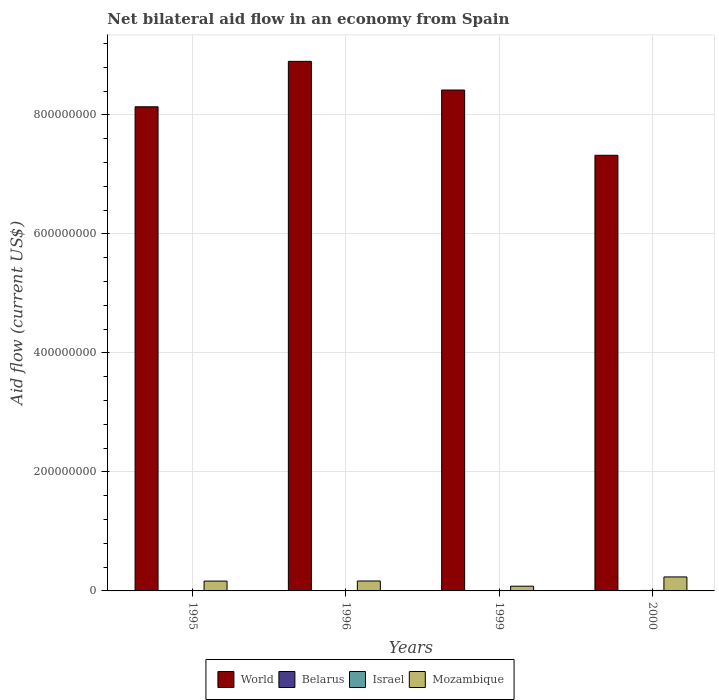In how many cases, is the number of bars for a given year not equal to the number of legend labels?
Make the answer very short. 0. What is the net bilateral aid flow in Belarus in 1996?
Keep it short and to the point. 2.50e+05. Across all years, what is the maximum net bilateral aid flow in Mozambique?
Your response must be concise. 2.35e+07. Across all years, what is the minimum net bilateral aid flow in World?
Give a very brief answer. 7.32e+08. In which year was the net bilateral aid flow in World maximum?
Offer a very short reply. 1996. In which year was the net bilateral aid flow in World minimum?
Offer a terse response. 2000. What is the total net bilateral aid flow in Belarus in the graph?
Keep it short and to the point. 5.80e+05. What is the difference between the net bilateral aid flow in Mozambique in 1996 and that in 1999?
Ensure brevity in your answer.  8.74e+06. What is the difference between the net bilateral aid flow in Belarus in 1996 and the net bilateral aid flow in World in 1999?
Make the answer very short. -8.42e+08. What is the average net bilateral aid flow in Mozambique per year?
Keep it short and to the point. 1.62e+07. What is the ratio of the net bilateral aid flow in Mozambique in 1995 to that in 2000?
Provide a short and direct response. 0.7. What is the difference between the highest and the second highest net bilateral aid flow in Mozambique?
Keep it short and to the point. 6.83e+06. What is the difference between the highest and the lowest net bilateral aid flow in Mozambique?
Ensure brevity in your answer.  1.56e+07. In how many years, is the net bilateral aid flow in Belarus greater than the average net bilateral aid flow in Belarus taken over all years?
Give a very brief answer. 2. Is it the case that in every year, the sum of the net bilateral aid flow in Israel and net bilateral aid flow in World is greater than the sum of net bilateral aid flow in Belarus and net bilateral aid flow in Mozambique?
Give a very brief answer. Yes. What does the 1st bar from the left in 2000 represents?
Give a very brief answer. World. Is it the case that in every year, the sum of the net bilateral aid flow in Israel and net bilateral aid flow in Mozambique is greater than the net bilateral aid flow in World?
Offer a terse response. No. How many bars are there?
Provide a succinct answer. 16. Are all the bars in the graph horizontal?
Provide a short and direct response. No. What is the difference between two consecutive major ticks on the Y-axis?
Offer a very short reply. 2.00e+08. Does the graph contain grids?
Ensure brevity in your answer.  Yes. Where does the legend appear in the graph?
Offer a terse response. Bottom center. How many legend labels are there?
Make the answer very short. 4. What is the title of the graph?
Your response must be concise. Net bilateral aid flow in an economy from Spain. What is the Aid flow (current US$) of World in 1995?
Provide a succinct answer. 8.14e+08. What is the Aid flow (current US$) of Belarus in 1995?
Ensure brevity in your answer.  2.50e+05. What is the Aid flow (current US$) of Israel in 1995?
Keep it short and to the point. 1.10e+05. What is the Aid flow (current US$) of Mozambique in 1995?
Ensure brevity in your answer.  1.65e+07. What is the Aid flow (current US$) of World in 1996?
Your answer should be compact. 8.90e+08. What is the Aid flow (current US$) in Israel in 1996?
Ensure brevity in your answer.  1.50e+05. What is the Aid flow (current US$) of Mozambique in 1996?
Provide a short and direct response. 1.67e+07. What is the Aid flow (current US$) of World in 1999?
Provide a short and direct response. 8.42e+08. What is the Aid flow (current US$) of Belarus in 1999?
Keep it short and to the point. 5.00e+04. What is the Aid flow (current US$) in Israel in 1999?
Offer a very short reply. 7.20e+05. What is the Aid flow (current US$) in Mozambique in 1999?
Make the answer very short. 7.95e+06. What is the Aid flow (current US$) of World in 2000?
Offer a very short reply. 7.32e+08. What is the Aid flow (current US$) in Israel in 2000?
Offer a terse response. 8.10e+05. What is the Aid flow (current US$) in Mozambique in 2000?
Give a very brief answer. 2.35e+07. Across all years, what is the maximum Aid flow (current US$) of World?
Ensure brevity in your answer.  8.90e+08. Across all years, what is the maximum Aid flow (current US$) in Belarus?
Make the answer very short. 2.50e+05. Across all years, what is the maximum Aid flow (current US$) in Israel?
Provide a succinct answer. 8.10e+05. Across all years, what is the maximum Aid flow (current US$) of Mozambique?
Provide a succinct answer. 2.35e+07. Across all years, what is the minimum Aid flow (current US$) in World?
Your response must be concise. 7.32e+08. Across all years, what is the minimum Aid flow (current US$) in Belarus?
Your answer should be compact. 3.00e+04. Across all years, what is the minimum Aid flow (current US$) in Mozambique?
Keep it short and to the point. 7.95e+06. What is the total Aid flow (current US$) in World in the graph?
Make the answer very short. 3.28e+09. What is the total Aid flow (current US$) in Belarus in the graph?
Keep it short and to the point. 5.80e+05. What is the total Aid flow (current US$) of Israel in the graph?
Ensure brevity in your answer.  1.79e+06. What is the total Aid flow (current US$) in Mozambique in the graph?
Offer a terse response. 6.47e+07. What is the difference between the Aid flow (current US$) of World in 1995 and that in 1996?
Ensure brevity in your answer.  -7.64e+07. What is the difference between the Aid flow (current US$) of Mozambique in 1995 and that in 1996?
Provide a succinct answer. -1.60e+05. What is the difference between the Aid flow (current US$) of World in 1995 and that in 1999?
Provide a succinct answer. -2.82e+07. What is the difference between the Aid flow (current US$) of Israel in 1995 and that in 1999?
Make the answer very short. -6.10e+05. What is the difference between the Aid flow (current US$) of Mozambique in 1995 and that in 1999?
Offer a very short reply. 8.58e+06. What is the difference between the Aid flow (current US$) of World in 1995 and that in 2000?
Offer a very short reply. 8.15e+07. What is the difference between the Aid flow (current US$) in Israel in 1995 and that in 2000?
Provide a succinct answer. -7.00e+05. What is the difference between the Aid flow (current US$) of Mozambique in 1995 and that in 2000?
Provide a short and direct response. -6.99e+06. What is the difference between the Aid flow (current US$) of World in 1996 and that in 1999?
Offer a terse response. 4.82e+07. What is the difference between the Aid flow (current US$) in Israel in 1996 and that in 1999?
Offer a terse response. -5.70e+05. What is the difference between the Aid flow (current US$) in Mozambique in 1996 and that in 1999?
Your answer should be compact. 8.74e+06. What is the difference between the Aid flow (current US$) of World in 1996 and that in 2000?
Offer a terse response. 1.58e+08. What is the difference between the Aid flow (current US$) in Israel in 1996 and that in 2000?
Your response must be concise. -6.60e+05. What is the difference between the Aid flow (current US$) in Mozambique in 1996 and that in 2000?
Keep it short and to the point. -6.83e+06. What is the difference between the Aid flow (current US$) of World in 1999 and that in 2000?
Your response must be concise. 1.10e+08. What is the difference between the Aid flow (current US$) in Mozambique in 1999 and that in 2000?
Offer a terse response. -1.56e+07. What is the difference between the Aid flow (current US$) of World in 1995 and the Aid flow (current US$) of Belarus in 1996?
Provide a succinct answer. 8.13e+08. What is the difference between the Aid flow (current US$) in World in 1995 and the Aid flow (current US$) in Israel in 1996?
Offer a terse response. 8.13e+08. What is the difference between the Aid flow (current US$) of World in 1995 and the Aid flow (current US$) of Mozambique in 1996?
Keep it short and to the point. 7.97e+08. What is the difference between the Aid flow (current US$) in Belarus in 1995 and the Aid flow (current US$) in Israel in 1996?
Your answer should be very brief. 1.00e+05. What is the difference between the Aid flow (current US$) in Belarus in 1995 and the Aid flow (current US$) in Mozambique in 1996?
Provide a short and direct response. -1.64e+07. What is the difference between the Aid flow (current US$) in Israel in 1995 and the Aid flow (current US$) in Mozambique in 1996?
Offer a terse response. -1.66e+07. What is the difference between the Aid flow (current US$) in World in 1995 and the Aid flow (current US$) in Belarus in 1999?
Make the answer very short. 8.14e+08. What is the difference between the Aid flow (current US$) of World in 1995 and the Aid flow (current US$) of Israel in 1999?
Keep it short and to the point. 8.13e+08. What is the difference between the Aid flow (current US$) of World in 1995 and the Aid flow (current US$) of Mozambique in 1999?
Provide a short and direct response. 8.06e+08. What is the difference between the Aid flow (current US$) in Belarus in 1995 and the Aid flow (current US$) in Israel in 1999?
Offer a terse response. -4.70e+05. What is the difference between the Aid flow (current US$) in Belarus in 1995 and the Aid flow (current US$) in Mozambique in 1999?
Ensure brevity in your answer.  -7.70e+06. What is the difference between the Aid flow (current US$) of Israel in 1995 and the Aid flow (current US$) of Mozambique in 1999?
Offer a terse response. -7.84e+06. What is the difference between the Aid flow (current US$) of World in 1995 and the Aid flow (current US$) of Belarus in 2000?
Offer a very short reply. 8.14e+08. What is the difference between the Aid flow (current US$) of World in 1995 and the Aid flow (current US$) of Israel in 2000?
Make the answer very short. 8.13e+08. What is the difference between the Aid flow (current US$) in World in 1995 and the Aid flow (current US$) in Mozambique in 2000?
Your answer should be compact. 7.90e+08. What is the difference between the Aid flow (current US$) of Belarus in 1995 and the Aid flow (current US$) of Israel in 2000?
Your answer should be very brief. -5.60e+05. What is the difference between the Aid flow (current US$) of Belarus in 1995 and the Aid flow (current US$) of Mozambique in 2000?
Your answer should be very brief. -2.33e+07. What is the difference between the Aid flow (current US$) in Israel in 1995 and the Aid flow (current US$) in Mozambique in 2000?
Make the answer very short. -2.34e+07. What is the difference between the Aid flow (current US$) of World in 1996 and the Aid flow (current US$) of Belarus in 1999?
Give a very brief answer. 8.90e+08. What is the difference between the Aid flow (current US$) in World in 1996 and the Aid flow (current US$) in Israel in 1999?
Offer a very short reply. 8.89e+08. What is the difference between the Aid flow (current US$) in World in 1996 and the Aid flow (current US$) in Mozambique in 1999?
Give a very brief answer. 8.82e+08. What is the difference between the Aid flow (current US$) of Belarus in 1996 and the Aid flow (current US$) of Israel in 1999?
Provide a succinct answer. -4.70e+05. What is the difference between the Aid flow (current US$) of Belarus in 1996 and the Aid flow (current US$) of Mozambique in 1999?
Provide a succinct answer. -7.70e+06. What is the difference between the Aid flow (current US$) in Israel in 1996 and the Aid flow (current US$) in Mozambique in 1999?
Your answer should be very brief. -7.80e+06. What is the difference between the Aid flow (current US$) in World in 1996 and the Aid flow (current US$) in Belarus in 2000?
Offer a very short reply. 8.90e+08. What is the difference between the Aid flow (current US$) of World in 1996 and the Aid flow (current US$) of Israel in 2000?
Provide a succinct answer. 8.89e+08. What is the difference between the Aid flow (current US$) of World in 1996 and the Aid flow (current US$) of Mozambique in 2000?
Provide a short and direct response. 8.66e+08. What is the difference between the Aid flow (current US$) of Belarus in 1996 and the Aid flow (current US$) of Israel in 2000?
Offer a very short reply. -5.60e+05. What is the difference between the Aid flow (current US$) in Belarus in 1996 and the Aid flow (current US$) in Mozambique in 2000?
Offer a very short reply. -2.33e+07. What is the difference between the Aid flow (current US$) in Israel in 1996 and the Aid flow (current US$) in Mozambique in 2000?
Give a very brief answer. -2.34e+07. What is the difference between the Aid flow (current US$) in World in 1999 and the Aid flow (current US$) in Belarus in 2000?
Provide a succinct answer. 8.42e+08. What is the difference between the Aid flow (current US$) in World in 1999 and the Aid flow (current US$) in Israel in 2000?
Give a very brief answer. 8.41e+08. What is the difference between the Aid flow (current US$) of World in 1999 and the Aid flow (current US$) of Mozambique in 2000?
Give a very brief answer. 8.18e+08. What is the difference between the Aid flow (current US$) in Belarus in 1999 and the Aid flow (current US$) in Israel in 2000?
Offer a terse response. -7.60e+05. What is the difference between the Aid flow (current US$) in Belarus in 1999 and the Aid flow (current US$) in Mozambique in 2000?
Give a very brief answer. -2.35e+07. What is the difference between the Aid flow (current US$) of Israel in 1999 and the Aid flow (current US$) of Mozambique in 2000?
Ensure brevity in your answer.  -2.28e+07. What is the average Aid flow (current US$) in World per year?
Your answer should be very brief. 8.19e+08. What is the average Aid flow (current US$) of Belarus per year?
Your answer should be compact. 1.45e+05. What is the average Aid flow (current US$) in Israel per year?
Provide a short and direct response. 4.48e+05. What is the average Aid flow (current US$) of Mozambique per year?
Offer a very short reply. 1.62e+07. In the year 1995, what is the difference between the Aid flow (current US$) in World and Aid flow (current US$) in Belarus?
Your response must be concise. 8.13e+08. In the year 1995, what is the difference between the Aid flow (current US$) in World and Aid flow (current US$) in Israel?
Make the answer very short. 8.14e+08. In the year 1995, what is the difference between the Aid flow (current US$) of World and Aid flow (current US$) of Mozambique?
Your answer should be very brief. 7.97e+08. In the year 1995, what is the difference between the Aid flow (current US$) of Belarus and Aid flow (current US$) of Israel?
Your response must be concise. 1.40e+05. In the year 1995, what is the difference between the Aid flow (current US$) in Belarus and Aid flow (current US$) in Mozambique?
Ensure brevity in your answer.  -1.63e+07. In the year 1995, what is the difference between the Aid flow (current US$) in Israel and Aid flow (current US$) in Mozambique?
Your answer should be very brief. -1.64e+07. In the year 1996, what is the difference between the Aid flow (current US$) of World and Aid flow (current US$) of Belarus?
Offer a very short reply. 8.90e+08. In the year 1996, what is the difference between the Aid flow (current US$) of World and Aid flow (current US$) of Israel?
Your answer should be compact. 8.90e+08. In the year 1996, what is the difference between the Aid flow (current US$) in World and Aid flow (current US$) in Mozambique?
Make the answer very short. 8.73e+08. In the year 1996, what is the difference between the Aid flow (current US$) in Belarus and Aid flow (current US$) in Israel?
Provide a short and direct response. 1.00e+05. In the year 1996, what is the difference between the Aid flow (current US$) in Belarus and Aid flow (current US$) in Mozambique?
Your answer should be very brief. -1.64e+07. In the year 1996, what is the difference between the Aid flow (current US$) of Israel and Aid flow (current US$) of Mozambique?
Ensure brevity in your answer.  -1.65e+07. In the year 1999, what is the difference between the Aid flow (current US$) of World and Aid flow (current US$) of Belarus?
Your response must be concise. 8.42e+08. In the year 1999, what is the difference between the Aid flow (current US$) in World and Aid flow (current US$) in Israel?
Ensure brevity in your answer.  8.41e+08. In the year 1999, what is the difference between the Aid flow (current US$) of World and Aid flow (current US$) of Mozambique?
Ensure brevity in your answer.  8.34e+08. In the year 1999, what is the difference between the Aid flow (current US$) in Belarus and Aid flow (current US$) in Israel?
Make the answer very short. -6.70e+05. In the year 1999, what is the difference between the Aid flow (current US$) in Belarus and Aid flow (current US$) in Mozambique?
Your response must be concise. -7.90e+06. In the year 1999, what is the difference between the Aid flow (current US$) in Israel and Aid flow (current US$) in Mozambique?
Your answer should be very brief. -7.23e+06. In the year 2000, what is the difference between the Aid flow (current US$) of World and Aid flow (current US$) of Belarus?
Offer a very short reply. 7.32e+08. In the year 2000, what is the difference between the Aid flow (current US$) in World and Aid flow (current US$) in Israel?
Your answer should be very brief. 7.31e+08. In the year 2000, what is the difference between the Aid flow (current US$) in World and Aid flow (current US$) in Mozambique?
Make the answer very short. 7.09e+08. In the year 2000, what is the difference between the Aid flow (current US$) in Belarus and Aid flow (current US$) in Israel?
Your response must be concise. -7.80e+05. In the year 2000, what is the difference between the Aid flow (current US$) of Belarus and Aid flow (current US$) of Mozambique?
Your answer should be compact. -2.35e+07. In the year 2000, what is the difference between the Aid flow (current US$) in Israel and Aid flow (current US$) in Mozambique?
Offer a terse response. -2.27e+07. What is the ratio of the Aid flow (current US$) in World in 1995 to that in 1996?
Your answer should be compact. 0.91. What is the ratio of the Aid flow (current US$) in Israel in 1995 to that in 1996?
Ensure brevity in your answer.  0.73. What is the ratio of the Aid flow (current US$) in Mozambique in 1995 to that in 1996?
Provide a succinct answer. 0.99. What is the ratio of the Aid flow (current US$) in World in 1995 to that in 1999?
Provide a short and direct response. 0.97. What is the ratio of the Aid flow (current US$) in Belarus in 1995 to that in 1999?
Your answer should be very brief. 5. What is the ratio of the Aid flow (current US$) of Israel in 1995 to that in 1999?
Provide a succinct answer. 0.15. What is the ratio of the Aid flow (current US$) in Mozambique in 1995 to that in 1999?
Keep it short and to the point. 2.08. What is the ratio of the Aid flow (current US$) in World in 1995 to that in 2000?
Your answer should be very brief. 1.11. What is the ratio of the Aid flow (current US$) in Belarus in 1995 to that in 2000?
Keep it short and to the point. 8.33. What is the ratio of the Aid flow (current US$) of Israel in 1995 to that in 2000?
Keep it short and to the point. 0.14. What is the ratio of the Aid flow (current US$) in Mozambique in 1995 to that in 2000?
Offer a very short reply. 0.7. What is the ratio of the Aid flow (current US$) of World in 1996 to that in 1999?
Give a very brief answer. 1.06. What is the ratio of the Aid flow (current US$) in Israel in 1996 to that in 1999?
Offer a terse response. 0.21. What is the ratio of the Aid flow (current US$) in Mozambique in 1996 to that in 1999?
Give a very brief answer. 2.1. What is the ratio of the Aid flow (current US$) of World in 1996 to that in 2000?
Ensure brevity in your answer.  1.22. What is the ratio of the Aid flow (current US$) of Belarus in 1996 to that in 2000?
Your answer should be compact. 8.33. What is the ratio of the Aid flow (current US$) of Israel in 1996 to that in 2000?
Your answer should be very brief. 0.19. What is the ratio of the Aid flow (current US$) in Mozambique in 1996 to that in 2000?
Your response must be concise. 0.71. What is the ratio of the Aid flow (current US$) of World in 1999 to that in 2000?
Your answer should be compact. 1.15. What is the ratio of the Aid flow (current US$) of Mozambique in 1999 to that in 2000?
Keep it short and to the point. 0.34. What is the difference between the highest and the second highest Aid flow (current US$) in World?
Provide a succinct answer. 4.82e+07. What is the difference between the highest and the second highest Aid flow (current US$) in Israel?
Give a very brief answer. 9.00e+04. What is the difference between the highest and the second highest Aid flow (current US$) in Mozambique?
Make the answer very short. 6.83e+06. What is the difference between the highest and the lowest Aid flow (current US$) of World?
Ensure brevity in your answer.  1.58e+08. What is the difference between the highest and the lowest Aid flow (current US$) in Israel?
Provide a short and direct response. 7.00e+05. What is the difference between the highest and the lowest Aid flow (current US$) in Mozambique?
Offer a terse response. 1.56e+07. 